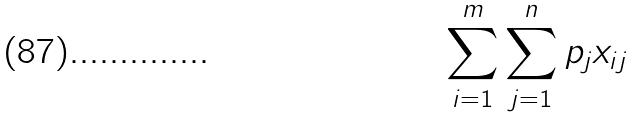<formula> <loc_0><loc_0><loc_500><loc_500>\sum _ { i = 1 } ^ { m } \sum _ { j = 1 } ^ { n } p _ { j } x _ { i j }</formula> 